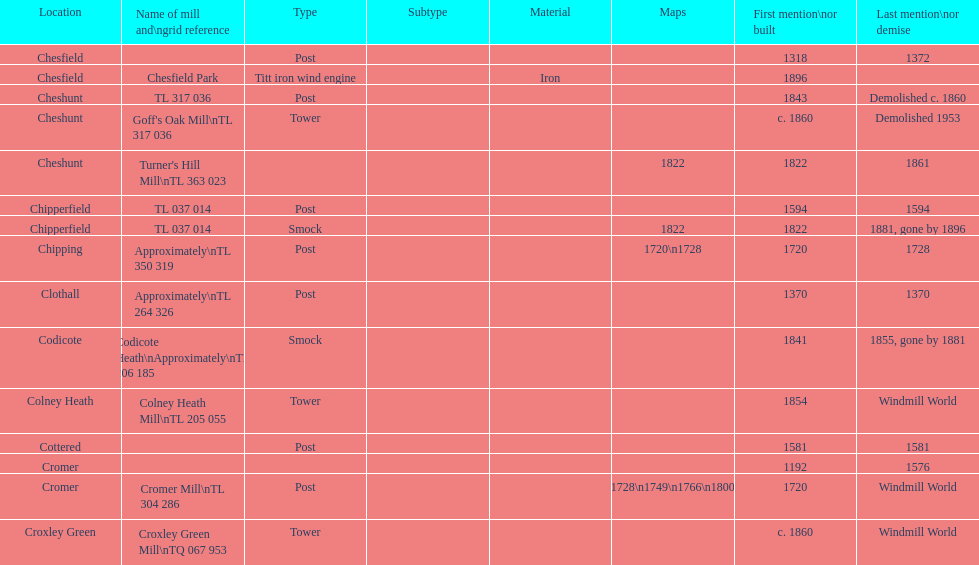How many locations have no photograph? 14. 